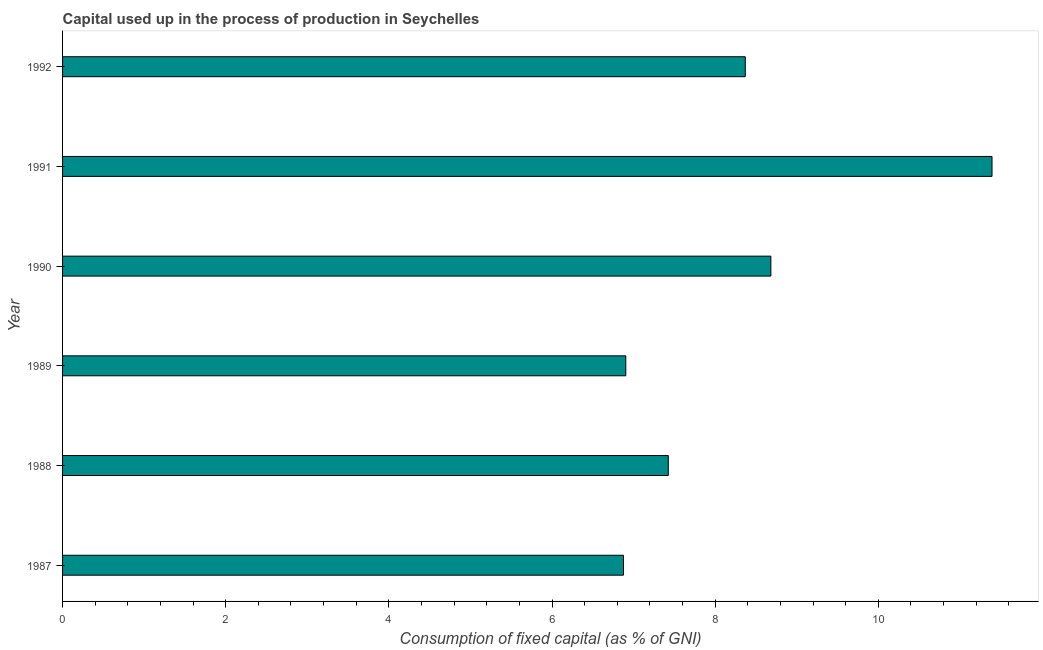Does the graph contain any zero values?
Provide a short and direct response. No. What is the title of the graph?
Your answer should be very brief. Capital used up in the process of production in Seychelles. What is the label or title of the X-axis?
Your answer should be very brief. Consumption of fixed capital (as % of GNI). What is the consumption of fixed capital in 1988?
Ensure brevity in your answer.  7.43. Across all years, what is the maximum consumption of fixed capital?
Provide a succinct answer. 11.39. Across all years, what is the minimum consumption of fixed capital?
Your answer should be very brief. 6.88. What is the sum of the consumption of fixed capital?
Your answer should be very brief. 49.65. What is the difference between the consumption of fixed capital in 1990 and 1992?
Offer a very short reply. 0.31. What is the average consumption of fixed capital per year?
Give a very brief answer. 8.28. What is the median consumption of fixed capital?
Provide a succinct answer. 7.9. Do a majority of the years between 1990 and 1987 (inclusive) have consumption of fixed capital greater than 6 %?
Your answer should be very brief. Yes. What is the ratio of the consumption of fixed capital in 1988 to that in 1991?
Provide a short and direct response. 0.65. Is the consumption of fixed capital in 1990 less than that in 1991?
Your response must be concise. Yes. Is the difference between the consumption of fixed capital in 1988 and 1990 greater than the difference between any two years?
Your response must be concise. No. What is the difference between the highest and the second highest consumption of fixed capital?
Offer a very short reply. 2.71. Is the sum of the consumption of fixed capital in 1989 and 1990 greater than the maximum consumption of fixed capital across all years?
Your answer should be compact. Yes. What is the difference between the highest and the lowest consumption of fixed capital?
Your response must be concise. 4.52. Are all the bars in the graph horizontal?
Keep it short and to the point. Yes. Are the values on the major ticks of X-axis written in scientific E-notation?
Provide a short and direct response. No. What is the Consumption of fixed capital (as % of GNI) in 1987?
Your response must be concise. 6.88. What is the Consumption of fixed capital (as % of GNI) in 1988?
Your response must be concise. 7.43. What is the Consumption of fixed capital (as % of GNI) of 1989?
Provide a succinct answer. 6.9. What is the Consumption of fixed capital (as % of GNI) of 1990?
Keep it short and to the point. 8.68. What is the Consumption of fixed capital (as % of GNI) of 1991?
Give a very brief answer. 11.39. What is the Consumption of fixed capital (as % of GNI) in 1992?
Make the answer very short. 8.37. What is the difference between the Consumption of fixed capital (as % of GNI) in 1987 and 1988?
Your response must be concise. -0.55. What is the difference between the Consumption of fixed capital (as % of GNI) in 1987 and 1989?
Provide a succinct answer. -0.03. What is the difference between the Consumption of fixed capital (as % of GNI) in 1987 and 1990?
Provide a short and direct response. -1.81. What is the difference between the Consumption of fixed capital (as % of GNI) in 1987 and 1991?
Provide a succinct answer. -4.52. What is the difference between the Consumption of fixed capital (as % of GNI) in 1987 and 1992?
Your answer should be compact. -1.49. What is the difference between the Consumption of fixed capital (as % of GNI) in 1988 and 1989?
Your response must be concise. 0.52. What is the difference between the Consumption of fixed capital (as % of GNI) in 1988 and 1990?
Offer a very short reply. -1.26. What is the difference between the Consumption of fixed capital (as % of GNI) in 1988 and 1991?
Ensure brevity in your answer.  -3.97. What is the difference between the Consumption of fixed capital (as % of GNI) in 1988 and 1992?
Ensure brevity in your answer.  -0.94. What is the difference between the Consumption of fixed capital (as % of GNI) in 1989 and 1990?
Give a very brief answer. -1.78. What is the difference between the Consumption of fixed capital (as % of GNI) in 1989 and 1991?
Your answer should be compact. -4.49. What is the difference between the Consumption of fixed capital (as % of GNI) in 1989 and 1992?
Offer a very short reply. -1.46. What is the difference between the Consumption of fixed capital (as % of GNI) in 1990 and 1991?
Make the answer very short. -2.71. What is the difference between the Consumption of fixed capital (as % of GNI) in 1990 and 1992?
Ensure brevity in your answer.  0.31. What is the difference between the Consumption of fixed capital (as % of GNI) in 1991 and 1992?
Your answer should be compact. 3.02. What is the ratio of the Consumption of fixed capital (as % of GNI) in 1987 to that in 1988?
Ensure brevity in your answer.  0.93. What is the ratio of the Consumption of fixed capital (as % of GNI) in 1987 to that in 1989?
Keep it short and to the point. 1. What is the ratio of the Consumption of fixed capital (as % of GNI) in 1987 to that in 1990?
Ensure brevity in your answer.  0.79. What is the ratio of the Consumption of fixed capital (as % of GNI) in 1987 to that in 1991?
Offer a very short reply. 0.6. What is the ratio of the Consumption of fixed capital (as % of GNI) in 1987 to that in 1992?
Provide a succinct answer. 0.82. What is the ratio of the Consumption of fixed capital (as % of GNI) in 1988 to that in 1989?
Provide a succinct answer. 1.07. What is the ratio of the Consumption of fixed capital (as % of GNI) in 1988 to that in 1990?
Your answer should be compact. 0.85. What is the ratio of the Consumption of fixed capital (as % of GNI) in 1988 to that in 1991?
Your answer should be very brief. 0.65. What is the ratio of the Consumption of fixed capital (as % of GNI) in 1988 to that in 1992?
Your response must be concise. 0.89. What is the ratio of the Consumption of fixed capital (as % of GNI) in 1989 to that in 1990?
Your answer should be compact. 0.8. What is the ratio of the Consumption of fixed capital (as % of GNI) in 1989 to that in 1991?
Ensure brevity in your answer.  0.61. What is the ratio of the Consumption of fixed capital (as % of GNI) in 1989 to that in 1992?
Keep it short and to the point. 0.82. What is the ratio of the Consumption of fixed capital (as % of GNI) in 1990 to that in 1991?
Your answer should be compact. 0.76. What is the ratio of the Consumption of fixed capital (as % of GNI) in 1991 to that in 1992?
Keep it short and to the point. 1.36. 